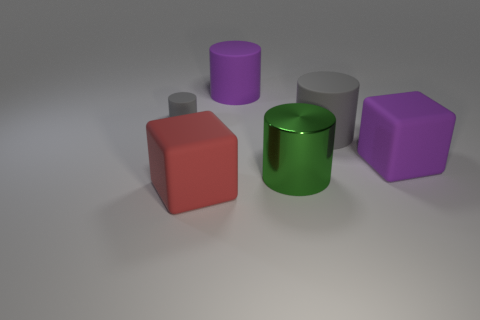Subtract 1 cylinders. How many cylinders are left? 3 Add 4 large blue balls. How many objects exist? 10 Subtract all cubes. How many objects are left? 4 Add 3 big red cubes. How many big red cubes are left? 4 Add 4 cyan rubber blocks. How many cyan rubber blocks exist? 4 Subtract 0 blue cubes. How many objects are left? 6 Subtract all large red rubber things. Subtract all matte cubes. How many objects are left? 3 